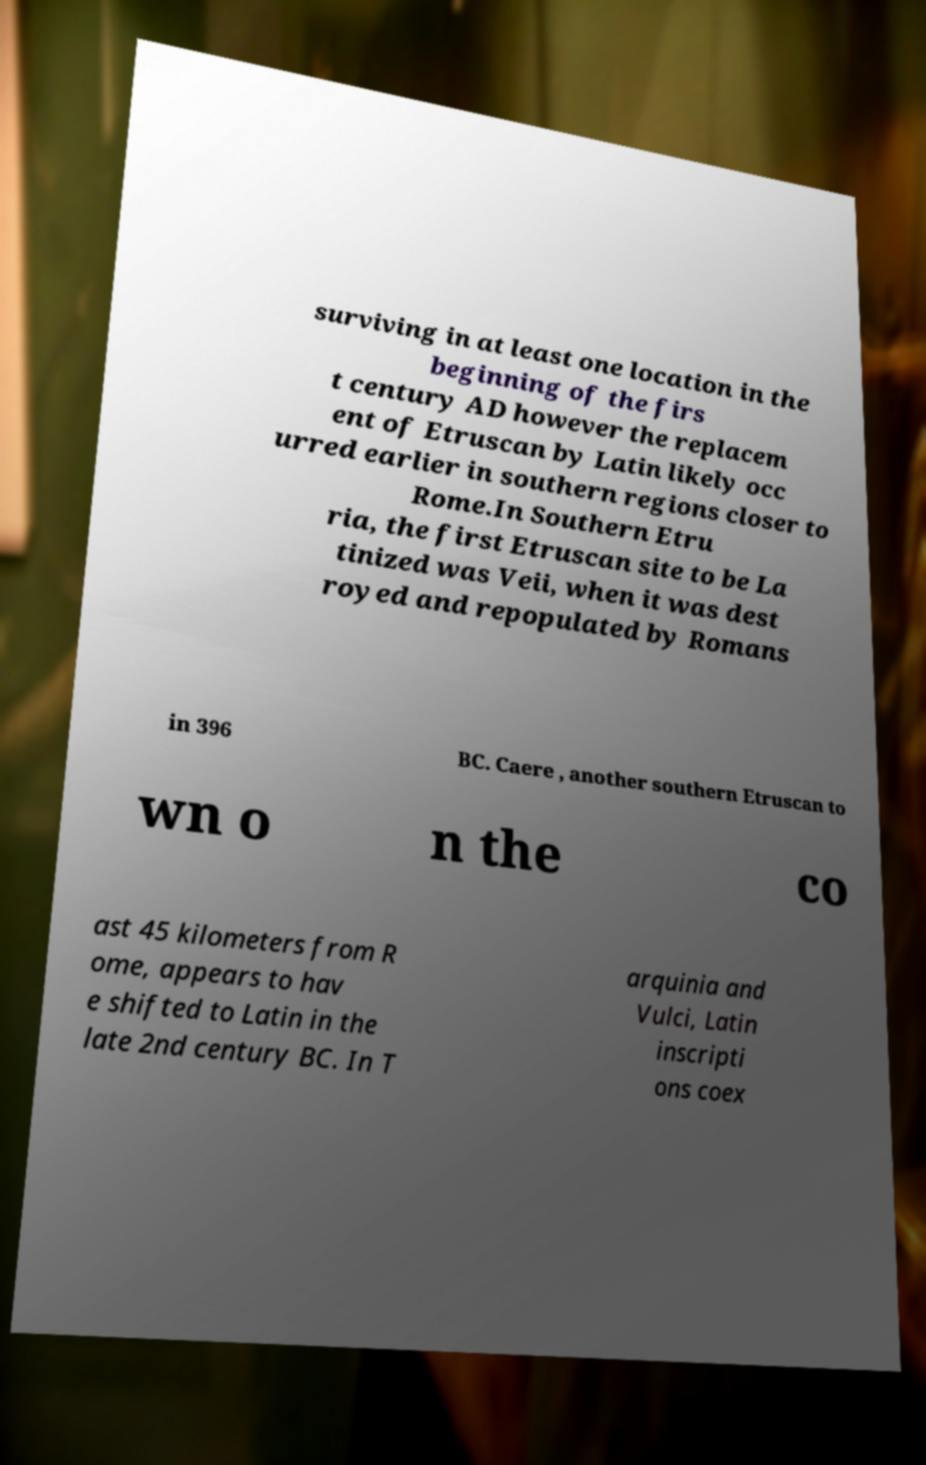Can you read and provide the text displayed in the image?This photo seems to have some interesting text. Can you extract and type it out for me? surviving in at least one location in the beginning of the firs t century AD however the replacem ent of Etruscan by Latin likely occ urred earlier in southern regions closer to Rome.In Southern Etru ria, the first Etruscan site to be La tinized was Veii, when it was dest royed and repopulated by Romans in 396 BC. Caere , another southern Etruscan to wn o n the co ast 45 kilometers from R ome, appears to hav e shifted to Latin in the late 2nd century BC. In T arquinia and Vulci, Latin inscripti ons coex 